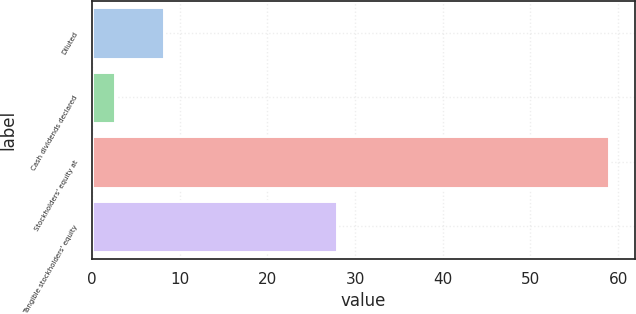Convert chart. <chart><loc_0><loc_0><loc_500><loc_500><bar_chart><fcel>Diluted<fcel>Cash dividends declared<fcel>Stockholders' equity at<fcel>Tangible stockholders' equity<nl><fcel>8.24<fcel>2.6<fcel>58.99<fcel>27.98<nl></chart> 